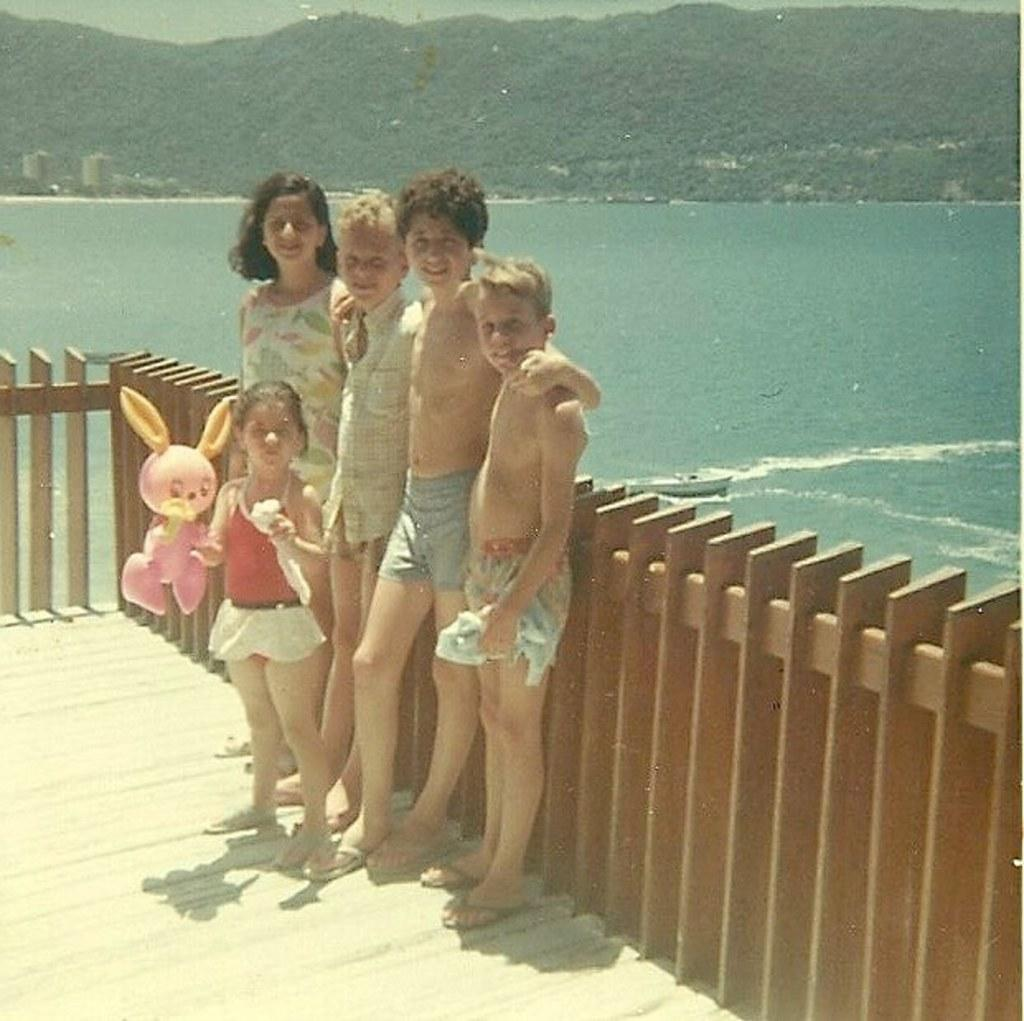What types of people are in the image? There are boys and girls in the image. What is a girl doing in the image? A girl is holding a toy in her hand. What can be seen in the background of the image? There is a wooden fence and trees visible in the image. What is located near the water in the image? There is a boat in the water in the image. What type of drain can be seen in the image? There is no drain present in the image. Are the boys and girls talking to each other in the image? The conversation does not mention whether the boys and girls are talking to each other, so we cannot definitively answer that question. 